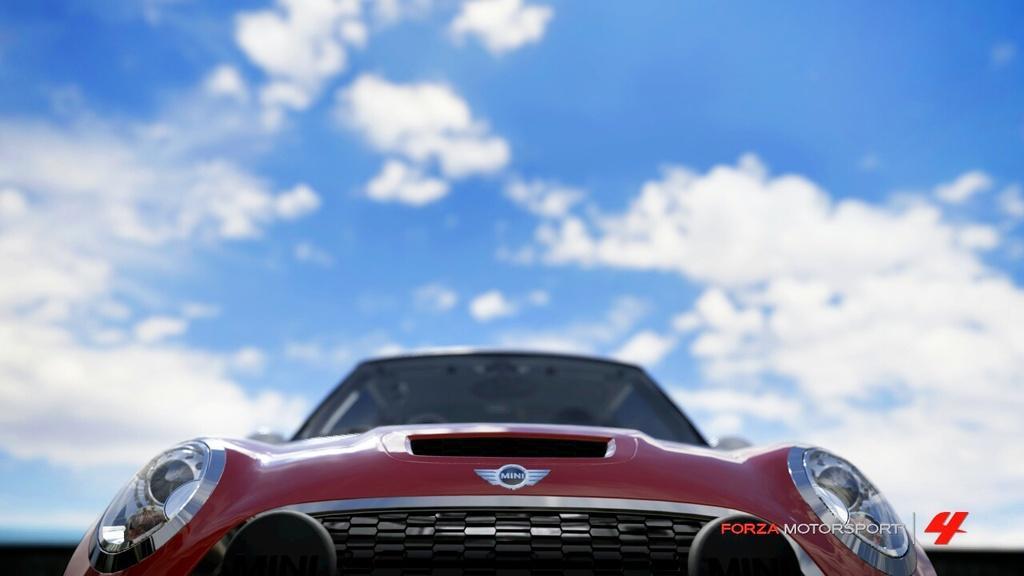In one or two sentences, can you explain what this image depicts? In this image at the bottom there is one vehicle, and there is some text at the bottom and at the top there is sky. 